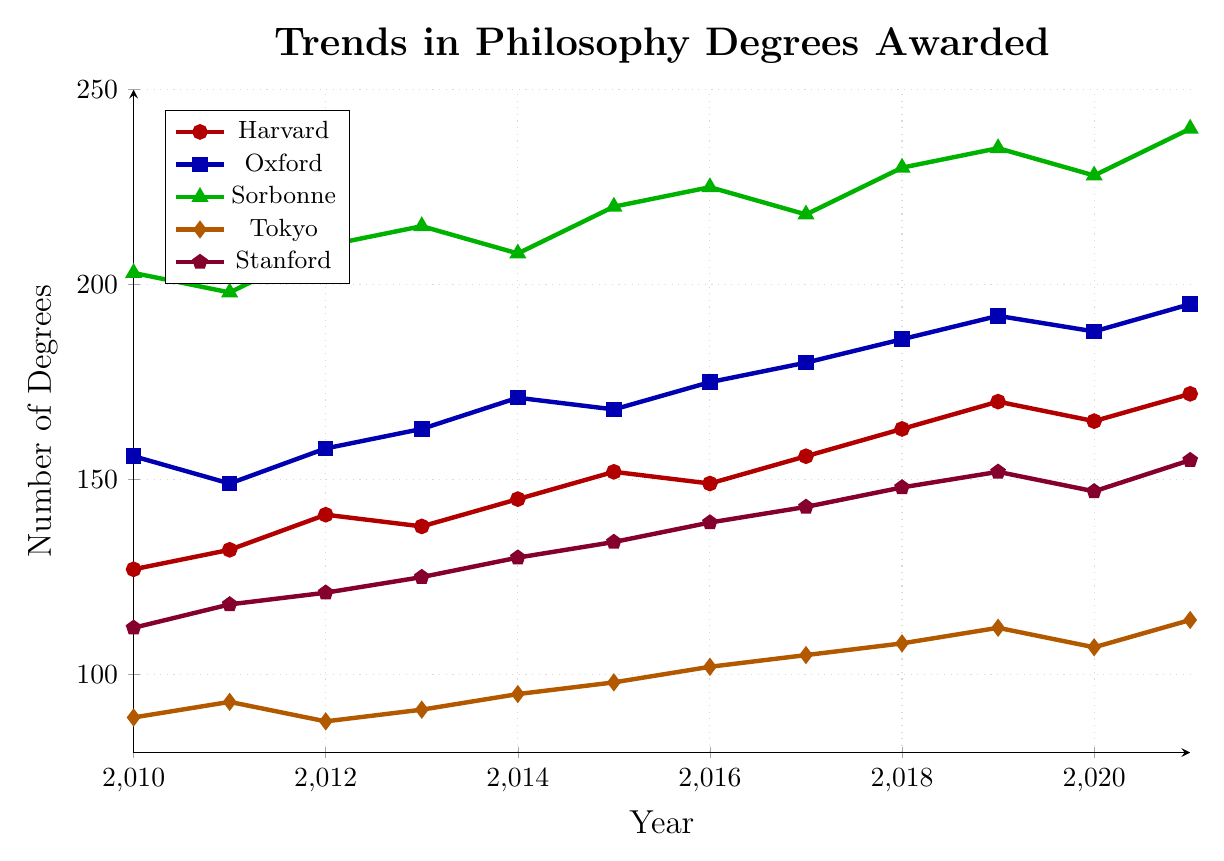What are the trends in the number of philosophy degrees awarded at Harvard from 2010 to 2021? From the chart, observe the trend line for Harvard, marked in red. The number increases from 127 in 2010 to a peak of 172 in 2021, except a slight dip around 2016.
Answer: A rising trend with minor fluctuations Which university awarded the highest number of philosophy degrees in 2021? Look at the end points of each university in the chart. Sorbonne University, marked in green, shows the highest endpoint at 240 degrees.
Answer: Sorbonne University Between Sorbonne and Oxford, which university saw a greater increase in philosophy degrees from 2010 to 2021? Sorbonne goes from 203 to 240, an increase of 37. Oxford goes from 156 to 195, an increase of 39. Compare these values.
Answer: Oxford University Which university had the least fluctuation in the number of degrees awarded? Observe the smoothness of the trend lines. University of Tokyo, marked in orange, has a relatively steady curve with little variation compared to others.
Answer: University of Tokyo What is the average number of degrees awarded at Stanford from 2010 to 2021? Sum the values for Stanford (112, 118, 121, 125, 130, 134, 139, 143, 148, 152, 147, 155) which gives 1644. Divide by the number of years (12).
Answer: 137 Which year shows a peak in the number of philosophy degrees awarded at Tokyo University? Look at the orange line for Tokyo University. Identify the peak value which occurs in 2021 with 114 degrees.
Answer: 2021 Compare the trends of Harvard and Sorbonne; which university shows a decrease in a single year from 2010 to 2021? Analyze the red line for Harvard and the green line for Sorbonne. Note the drop in degrees for Sorbonne from 2014 to 2015 and from 2019 to 2020; Harvard also decreases from 2012 to 2013.
Answer: Both What is the cumulative total of degrees awarded by Oxford University from 2010 to 2021? Sum the values for Oxford (156, 149, 158, 163, 171, 168, 175, 180, 186, 192, 188, 195). The sum is 2081.
Answer: 2081 Does any university show a consistent annual increase in degrees awarded from 2010 to 2021? Look for trend lines without drops. None of the universities maintain a purely consistent upward trend – all have fluctuations.
Answer: No How many degrees were awarded by Sorbonne University in the midpoint year of 2015? Identify the coordinates for Sorbonne in 2015, which shows 220 degrees.
Answer: 220 